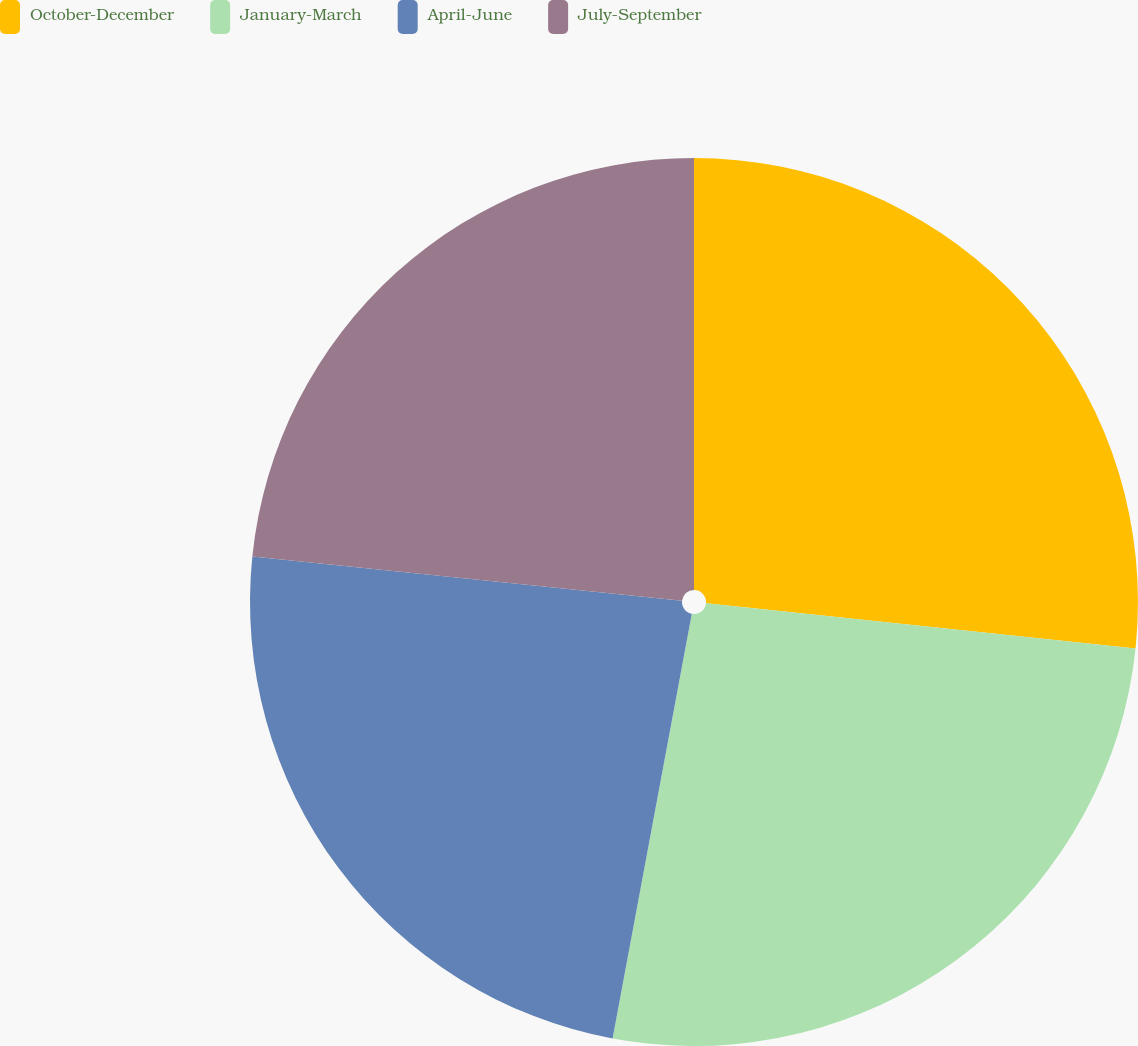Convert chart to OTSL. <chart><loc_0><loc_0><loc_500><loc_500><pie_chart><fcel>October-December<fcel>January-March<fcel>April-June<fcel>July-September<nl><fcel>26.67%<fcel>26.27%<fcel>23.7%<fcel>23.37%<nl></chart> 